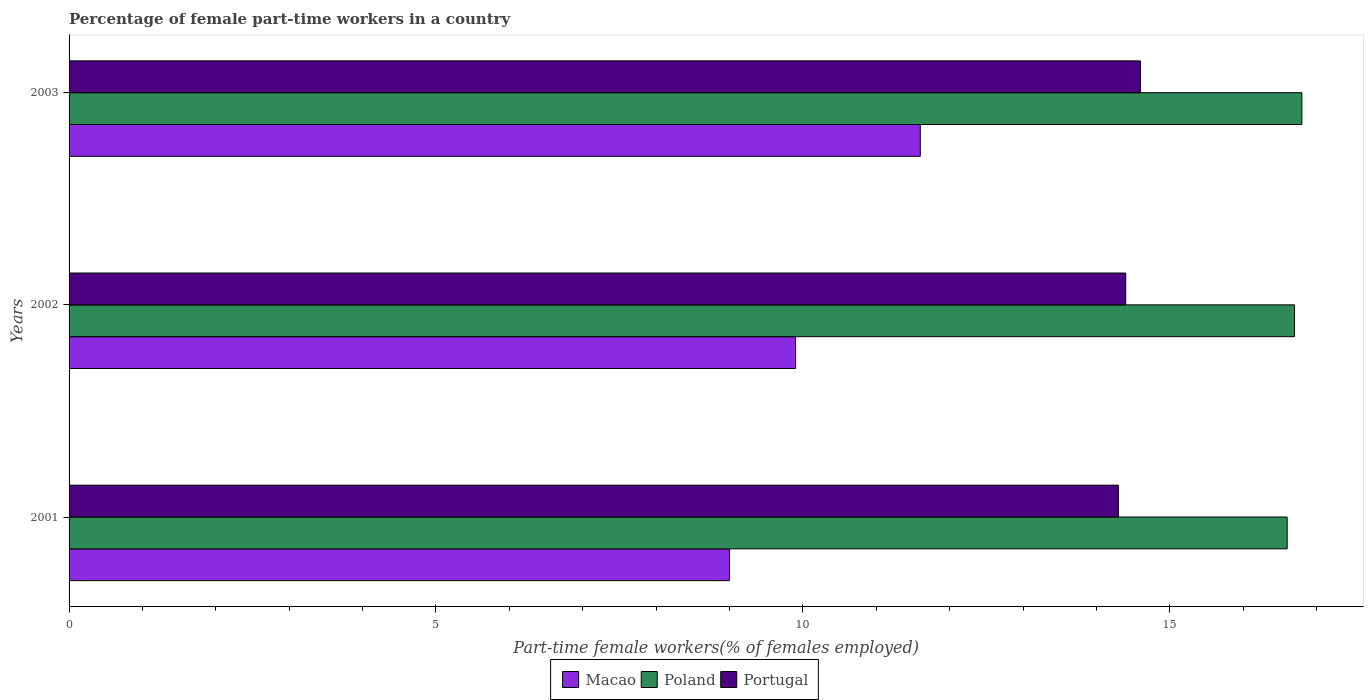How many groups of bars are there?
Offer a terse response. 3. How many bars are there on the 1st tick from the top?
Provide a short and direct response. 3. In how many cases, is the number of bars for a given year not equal to the number of legend labels?
Your answer should be compact. 0. What is the percentage of female part-time workers in Macao in 2002?
Offer a terse response. 9.9. Across all years, what is the maximum percentage of female part-time workers in Poland?
Ensure brevity in your answer.  16.8. What is the total percentage of female part-time workers in Poland in the graph?
Give a very brief answer. 50.1. What is the difference between the percentage of female part-time workers in Poland in 2001 and that in 2003?
Give a very brief answer. -0.2. What is the difference between the percentage of female part-time workers in Poland in 2001 and the percentage of female part-time workers in Macao in 2003?
Keep it short and to the point. 5. What is the average percentage of female part-time workers in Poland per year?
Keep it short and to the point. 16.7. In the year 2003, what is the difference between the percentage of female part-time workers in Poland and percentage of female part-time workers in Macao?
Provide a short and direct response. 5.2. In how many years, is the percentage of female part-time workers in Portugal greater than 14 %?
Offer a terse response. 3. What is the ratio of the percentage of female part-time workers in Poland in 2002 to that in 2003?
Your answer should be compact. 0.99. Is the percentage of female part-time workers in Macao in 2002 less than that in 2003?
Provide a short and direct response. Yes. Is the difference between the percentage of female part-time workers in Poland in 2001 and 2003 greater than the difference between the percentage of female part-time workers in Macao in 2001 and 2003?
Provide a succinct answer. Yes. What is the difference between the highest and the second highest percentage of female part-time workers in Macao?
Offer a very short reply. 1.7. What is the difference between the highest and the lowest percentage of female part-time workers in Poland?
Provide a succinct answer. 0.2. Is the sum of the percentage of female part-time workers in Poland in 2001 and 2002 greater than the maximum percentage of female part-time workers in Portugal across all years?
Your answer should be very brief. Yes. What does the 1st bar from the top in 2002 represents?
Your answer should be very brief. Portugal. What does the 3rd bar from the bottom in 2003 represents?
Keep it short and to the point. Portugal. Where does the legend appear in the graph?
Your answer should be very brief. Bottom center. What is the title of the graph?
Your answer should be very brief. Percentage of female part-time workers in a country. What is the label or title of the X-axis?
Your answer should be compact. Part-time female workers(% of females employed). What is the label or title of the Y-axis?
Keep it short and to the point. Years. What is the Part-time female workers(% of females employed) in Poland in 2001?
Your answer should be very brief. 16.6. What is the Part-time female workers(% of females employed) of Portugal in 2001?
Ensure brevity in your answer.  14.3. What is the Part-time female workers(% of females employed) in Macao in 2002?
Provide a short and direct response. 9.9. What is the Part-time female workers(% of females employed) in Poland in 2002?
Offer a terse response. 16.7. What is the Part-time female workers(% of females employed) in Portugal in 2002?
Keep it short and to the point. 14.4. What is the Part-time female workers(% of females employed) of Macao in 2003?
Your response must be concise. 11.6. What is the Part-time female workers(% of females employed) of Poland in 2003?
Provide a succinct answer. 16.8. What is the Part-time female workers(% of females employed) in Portugal in 2003?
Ensure brevity in your answer.  14.6. Across all years, what is the maximum Part-time female workers(% of females employed) of Macao?
Provide a short and direct response. 11.6. Across all years, what is the maximum Part-time female workers(% of females employed) in Poland?
Keep it short and to the point. 16.8. Across all years, what is the maximum Part-time female workers(% of females employed) in Portugal?
Offer a terse response. 14.6. Across all years, what is the minimum Part-time female workers(% of females employed) of Poland?
Your answer should be very brief. 16.6. Across all years, what is the minimum Part-time female workers(% of females employed) in Portugal?
Your answer should be very brief. 14.3. What is the total Part-time female workers(% of females employed) in Macao in the graph?
Provide a short and direct response. 30.5. What is the total Part-time female workers(% of females employed) in Poland in the graph?
Your answer should be very brief. 50.1. What is the total Part-time female workers(% of females employed) of Portugal in the graph?
Make the answer very short. 43.3. What is the difference between the Part-time female workers(% of females employed) of Macao in 2001 and that in 2003?
Your answer should be compact. -2.6. What is the difference between the Part-time female workers(% of females employed) in Poland in 2001 and that in 2003?
Your answer should be very brief. -0.2. What is the difference between the Part-time female workers(% of females employed) of Portugal in 2002 and that in 2003?
Offer a very short reply. -0.2. What is the difference between the Part-time female workers(% of females employed) of Macao in 2001 and the Part-time female workers(% of females employed) of Poland in 2002?
Ensure brevity in your answer.  -7.7. What is the difference between the Part-time female workers(% of females employed) of Macao in 2001 and the Part-time female workers(% of females employed) of Portugal in 2002?
Ensure brevity in your answer.  -5.4. What is the difference between the Part-time female workers(% of females employed) in Poland in 2001 and the Part-time female workers(% of females employed) in Portugal in 2002?
Your answer should be very brief. 2.2. What is the difference between the Part-time female workers(% of females employed) in Macao in 2001 and the Part-time female workers(% of females employed) in Poland in 2003?
Your answer should be very brief. -7.8. What is the difference between the Part-time female workers(% of females employed) in Poland in 2001 and the Part-time female workers(% of females employed) in Portugal in 2003?
Your answer should be compact. 2. What is the difference between the Part-time female workers(% of females employed) of Poland in 2002 and the Part-time female workers(% of females employed) of Portugal in 2003?
Give a very brief answer. 2.1. What is the average Part-time female workers(% of females employed) of Macao per year?
Your response must be concise. 10.17. What is the average Part-time female workers(% of females employed) of Portugal per year?
Provide a succinct answer. 14.43. In the year 2001, what is the difference between the Part-time female workers(% of females employed) of Macao and Part-time female workers(% of females employed) of Poland?
Provide a short and direct response. -7.6. In the year 2002, what is the difference between the Part-time female workers(% of females employed) of Macao and Part-time female workers(% of females employed) of Poland?
Keep it short and to the point. -6.8. In the year 2003, what is the difference between the Part-time female workers(% of females employed) of Macao and Part-time female workers(% of females employed) of Poland?
Provide a short and direct response. -5.2. In the year 2003, what is the difference between the Part-time female workers(% of females employed) in Macao and Part-time female workers(% of females employed) in Portugal?
Your answer should be compact. -3. What is the ratio of the Part-time female workers(% of females employed) in Macao in 2001 to that in 2003?
Ensure brevity in your answer.  0.78. What is the ratio of the Part-time female workers(% of females employed) of Poland in 2001 to that in 2003?
Make the answer very short. 0.99. What is the ratio of the Part-time female workers(% of females employed) in Portugal in 2001 to that in 2003?
Your answer should be compact. 0.98. What is the ratio of the Part-time female workers(% of females employed) in Macao in 2002 to that in 2003?
Keep it short and to the point. 0.85. What is the ratio of the Part-time female workers(% of females employed) of Poland in 2002 to that in 2003?
Provide a succinct answer. 0.99. What is the ratio of the Part-time female workers(% of females employed) of Portugal in 2002 to that in 2003?
Give a very brief answer. 0.99. What is the difference between the highest and the second highest Part-time female workers(% of females employed) in Macao?
Make the answer very short. 1.7. What is the difference between the highest and the second highest Part-time female workers(% of females employed) in Poland?
Your answer should be compact. 0.1. What is the difference between the highest and the lowest Part-time female workers(% of females employed) in Macao?
Your answer should be very brief. 2.6. What is the difference between the highest and the lowest Part-time female workers(% of females employed) in Portugal?
Offer a terse response. 0.3. 